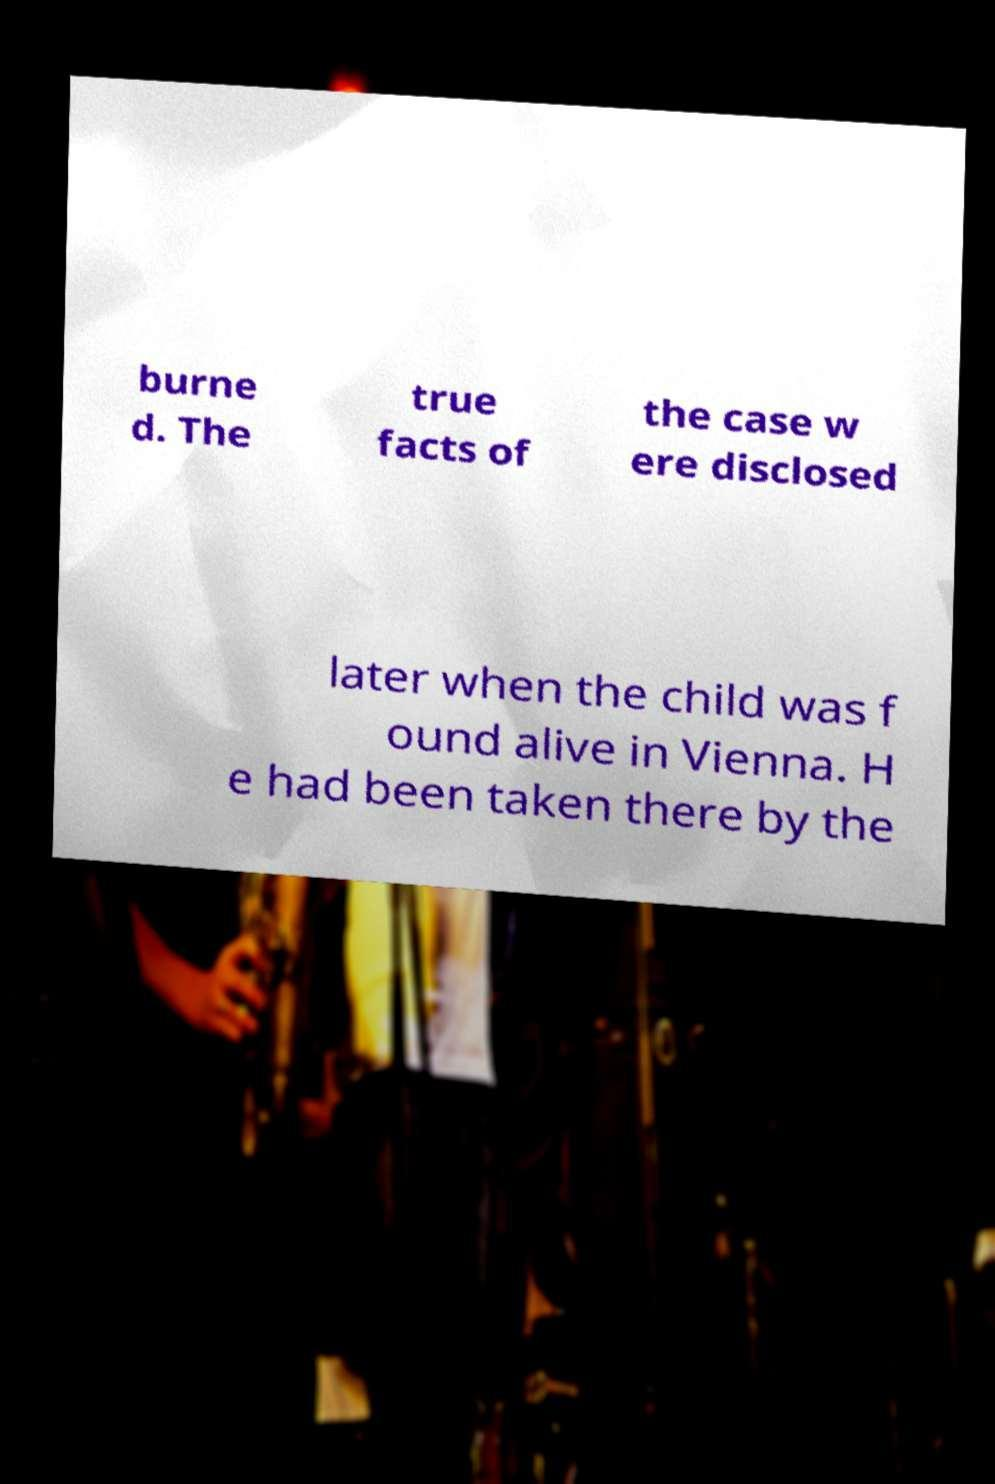Could you extract and type out the text from this image? burne d. The true facts of the case w ere disclosed later when the child was f ound alive in Vienna. H e had been taken there by the 